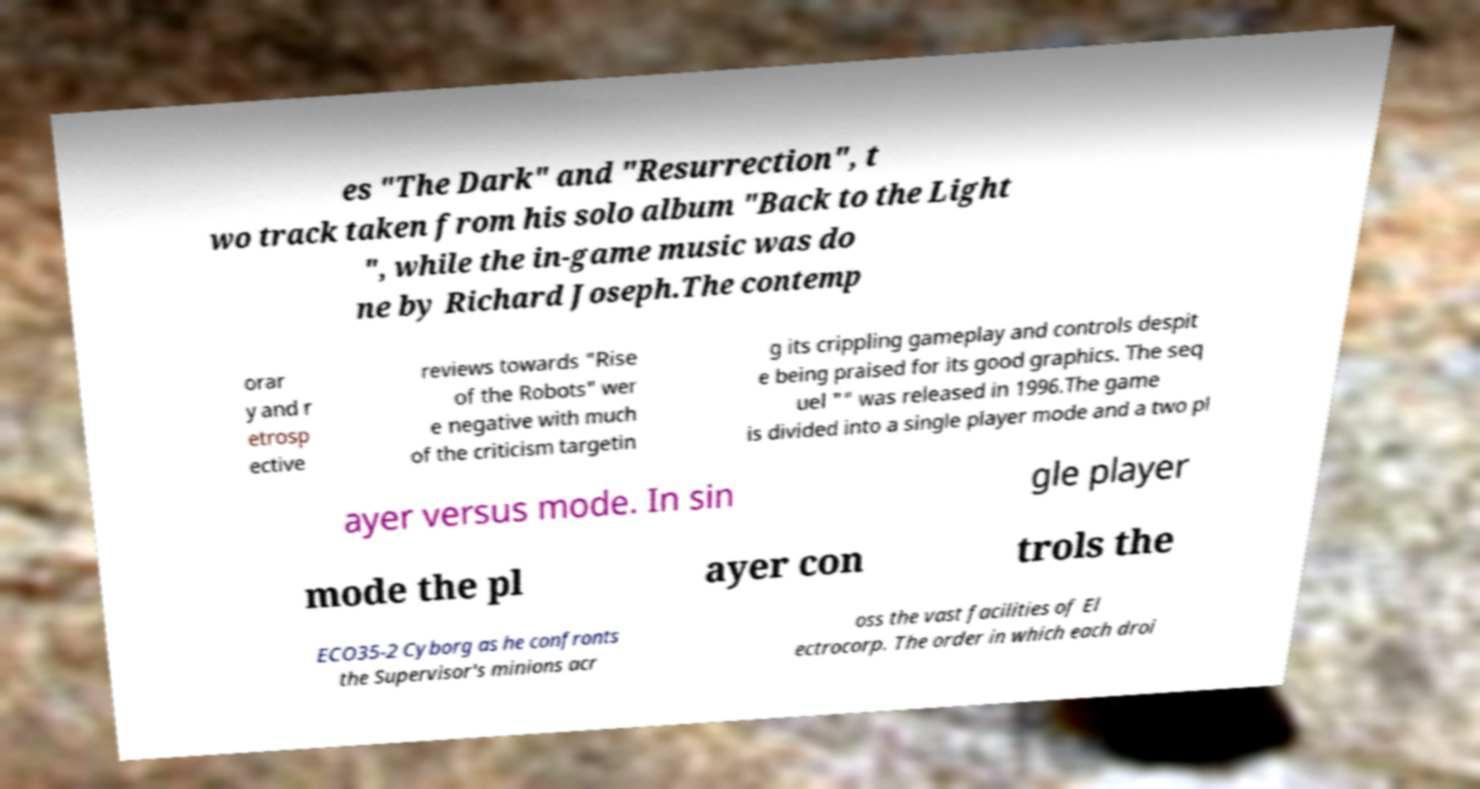Can you accurately transcribe the text from the provided image for me? es "The Dark" and "Resurrection", t wo track taken from his solo album "Back to the Light ", while the in-game music was do ne by Richard Joseph.The contemp orar y and r etrosp ective reviews towards "Rise of the Robots" wer e negative with much of the criticism targetin g its crippling gameplay and controls despit e being praised for its good graphics. The seq uel "" was released in 1996.The game is divided into a single player mode and a two pl ayer versus mode. In sin gle player mode the pl ayer con trols the ECO35-2 Cyborg as he confronts the Supervisor's minions acr oss the vast facilities of El ectrocorp. The order in which each droi 